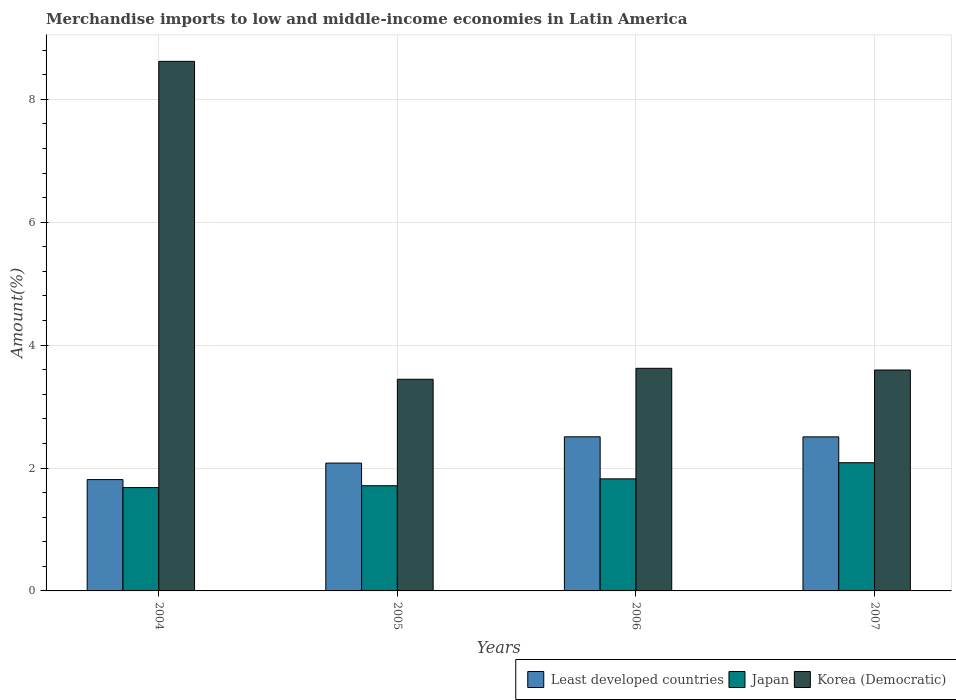Are the number of bars on each tick of the X-axis equal?
Your answer should be compact. Yes. How many bars are there on the 2nd tick from the left?
Keep it short and to the point. 3. What is the label of the 2nd group of bars from the left?
Provide a succinct answer. 2005. What is the percentage of amount earned from merchandise imports in Korea (Democratic) in 2005?
Keep it short and to the point. 3.44. Across all years, what is the maximum percentage of amount earned from merchandise imports in Korea (Democratic)?
Your response must be concise. 8.62. Across all years, what is the minimum percentage of amount earned from merchandise imports in Japan?
Make the answer very short. 1.68. What is the total percentage of amount earned from merchandise imports in Least developed countries in the graph?
Offer a very short reply. 8.91. What is the difference between the percentage of amount earned from merchandise imports in Least developed countries in 2005 and that in 2006?
Your response must be concise. -0.43. What is the difference between the percentage of amount earned from merchandise imports in Korea (Democratic) in 2005 and the percentage of amount earned from merchandise imports in Least developed countries in 2006?
Keep it short and to the point. 0.94. What is the average percentage of amount earned from merchandise imports in Japan per year?
Offer a terse response. 1.83. In the year 2004, what is the difference between the percentage of amount earned from merchandise imports in Korea (Democratic) and percentage of amount earned from merchandise imports in Least developed countries?
Provide a succinct answer. 6.81. What is the ratio of the percentage of amount earned from merchandise imports in Least developed countries in 2005 to that in 2007?
Your response must be concise. 0.83. Is the difference between the percentage of amount earned from merchandise imports in Korea (Democratic) in 2005 and 2006 greater than the difference between the percentage of amount earned from merchandise imports in Least developed countries in 2005 and 2006?
Ensure brevity in your answer.  Yes. What is the difference between the highest and the second highest percentage of amount earned from merchandise imports in Least developed countries?
Give a very brief answer. 0. What is the difference between the highest and the lowest percentage of amount earned from merchandise imports in Least developed countries?
Ensure brevity in your answer.  0.7. In how many years, is the percentage of amount earned from merchandise imports in Least developed countries greater than the average percentage of amount earned from merchandise imports in Least developed countries taken over all years?
Keep it short and to the point. 2. What does the 1st bar from the left in 2005 represents?
Ensure brevity in your answer.  Least developed countries. What does the 1st bar from the right in 2004 represents?
Make the answer very short. Korea (Democratic). How many bars are there?
Keep it short and to the point. 12. Are all the bars in the graph horizontal?
Offer a terse response. No. What is the difference between two consecutive major ticks on the Y-axis?
Provide a succinct answer. 2. Are the values on the major ticks of Y-axis written in scientific E-notation?
Give a very brief answer. No. Does the graph contain any zero values?
Offer a very short reply. No. Does the graph contain grids?
Your answer should be compact. Yes. How many legend labels are there?
Keep it short and to the point. 3. How are the legend labels stacked?
Your answer should be very brief. Horizontal. What is the title of the graph?
Your answer should be compact. Merchandise imports to low and middle-income economies in Latin America. What is the label or title of the Y-axis?
Give a very brief answer. Amount(%). What is the Amount(%) of Least developed countries in 2004?
Offer a very short reply. 1.81. What is the Amount(%) in Japan in 2004?
Your answer should be compact. 1.68. What is the Amount(%) in Korea (Democratic) in 2004?
Provide a succinct answer. 8.62. What is the Amount(%) of Least developed countries in 2005?
Give a very brief answer. 2.08. What is the Amount(%) in Japan in 2005?
Provide a succinct answer. 1.71. What is the Amount(%) of Korea (Democratic) in 2005?
Offer a terse response. 3.44. What is the Amount(%) of Least developed countries in 2006?
Give a very brief answer. 2.51. What is the Amount(%) in Japan in 2006?
Offer a terse response. 1.82. What is the Amount(%) of Korea (Democratic) in 2006?
Your answer should be compact. 3.62. What is the Amount(%) of Least developed countries in 2007?
Your answer should be very brief. 2.51. What is the Amount(%) of Japan in 2007?
Offer a terse response. 2.09. What is the Amount(%) of Korea (Democratic) in 2007?
Give a very brief answer. 3.59. Across all years, what is the maximum Amount(%) in Least developed countries?
Offer a terse response. 2.51. Across all years, what is the maximum Amount(%) of Japan?
Keep it short and to the point. 2.09. Across all years, what is the maximum Amount(%) of Korea (Democratic)?
Keep it short and to the point. 8.62. Across all years, what is the minimum Amount(%) of Least developed countries?
Your response must be concise. 1.81. Across all years, what is the minimum Amount(%) in Japan?
Keep it short and to the point. 1.68. Across all years, what is the minimum Amount(%) of Korea (Democratic)?
Make the answer very short. 3.44. What is the total Amount(%) in Least developed countries in the graph?
Your answer should be compact. 8.91. What is the total Amount(%) of Japan in the graph?
Your response must be concise. 7.3. What is the total Amount(%) of Korea (Democratic) in the graph?
Your answer should be very brief. 19.28. What is the difference between the Amount(%) in Least developed countries in 2004 and that in 2005?
Provide a short and direct response. -0.27. What is the difference between the Amount(%) of Japan in 2004 and that in 2005?
Offer a very short reply. -0.03. What is the difference between the Amount(%) of Korea (Democratic) in 2004 and that in 2005?
Offer a terse response. 5.17. What is the difference between the Amount(%) in Least developed countries in 2004 and that in 2006?
Offer a terse response. -0.7. What is the difference between the Amount(%) in Japan in 2004 and that in 2006?
Your answer should be very brief. -0.14. What is the difference between the Amount(%) of Korea (Democratic) in 2004 and that in 2006?
Give a very brief answer. 5. What is the difference between the Amount(%) in Least developed countries in 2004 and that in 2007?
Your response must be concise. -0.7. What is the difference between the Amount(%) of Japan in 2004 and that in 2007?
Offer a very short reply. -0.4. What is the difference between the Amount(%) in Korea (Democratic) in 2004 and that in 2007?
Offer a terse response. 5.02. What is the difference between the Amount(%) of Least developed countries in 2005 and that in 2006?
Keep it short and to the point. -0.43. What is the difference between the Amount(%) of Japan in 2005 and that in 2006?
Give a very brief answer. -0.11. What is the difference between the Amount(%) of Korea (Democratic) in 2005 and that in 2006?
Keep it short and to the point. -0.18. What is the difference between the Amount(%) in Least developed countries in 2005 and that in 2007?
Make the answer very short. -0.43. What is the difference between the Amount(%) in Japan in 2005 and that in 2007?
Offer a terse response. -0.37. What is the difference between the Amount(%) in Korea (Democratic) in 2005 and that in 2007?
Make the answer very short. -0.15. What is the difference between the Amount(%) of Least developed countries in 2006 and that in 2007?
Offer a very short reply. 0. What is the difference between the Amount(%) of Japan in 2006 and that in 2007?
Your answer should be compact. -0.26. What is the difference between the Amount(%) of Korea (Democratic) in 2006 and that in 2007?
Provide a succinct answer. 0.03. What is the difference between the Amount(%) of Least developed countries in 2004 and the Amount(%) of Japan in 2005?
Offer a very short reply. 0.1. What is the difference between the Amount(%) in Least developed countries in 2004 and the Amount(%) in Korea (Democratic) in 2005?
Offer a very short reply. -1.63. What is the difference between the Amount(%) of Japan in 2004 and the Amount(%) of Korea (Democratic) in 2005?
Provide a short and direct response. -1.76. What is the difference between the Amount(%) of Least developed countries in 2004 and the Amount(%) of Japan in 2006?
Your answer should be compact. -0.01. What is the difference between the Amount(%) in Least developed countries in 2004 and the Amount(%) in Korea (Democratic) in 2006?
Offer a terse response. -1.81. What is the difference between the Amount(%) in Japan in 2004 and the Amount(%) in Korea (Democratic) in 2006?
Your answer should be very brief. -1.94. What is the difference between the Amount(%) of Least developed countries in 2004 and the Amount(%) of Japan in 2007?
Provide a short and direct response. -0.27. What is the difference between the Amount(%) in Least developed countries in 2004 and the Amount(%) in Korea (Democratic) in 2007?
Offer a very short reply. -1.78. What is the difference between the Amount(%) in Japan in 2004 and the Amount(%) in Korea (Democratic) in 2007?
Offer a very short reply. -1.91. What is the difference between the Amount(%) of Least developed countries in 2005 and the Amount(%) of Japan in 2006?
Your answer should be compact. 0.26. What is the difference between the Amount(%) of Least developed countries in 2005 and the Amount(%) of Korea (Democratic) in 2006?
Keep it short and to the point. -1.54. What is the difference between the Amount(%) in Japan in 2005 and the Amount(%) in Korea (Democratic) in 2006?
Ensure brevity in your answer.  -1.91. What is the difference between the Amount(%) in Least developed countries in 2005 and the Amount(%) in Japan in 2007?
Keep it short and to the point. -0.01. What is the difference between the Amount(%) of Least developed countries in 2005 and the Amount(%) of Korea (Democratic) in 2007?
Your response must be concise. -1.51. What is the difference between the Amount(%) in Japan in 2005 and the Amount(%) in Korea (Democratic) in 2007?
Keep it short and to the point. -1.88. What is the difference between the Amount(%) in Least developed countries in 2006 and the Amount(%) in Japan in 2007?
Provide a short and direct response. 0.42. What is the difference between the Amount(%) in Least developed countries in 2006 and the Amount(%) in Korea (Democratic) in 2007?
Offer a terse response. -1.09. What is the difference between the Amount(%) of Japan in 2006 and the Amount(%) of Korea (Democratic) in 2007?
Keep it short and to the point. -1.77. What is the average Amount(%) of Least developed countries per year?
Make the answer very short. 2.23. What is the average Amount(%) of Japan per year?
Keep it short and to the point. 1.83. What is the average Amount(%) in Korea (Democratic) per year?
Offer a very short reply. 4.82. In the year 2004, what is the difference between the Amount(%) of Least developed countries and Amount(%) of Japan?
Give a very brief answer. 0.13. In the year 2004, what is the difference between the Amount(%) of Least developed countries and Amount(%) of Korea (Democratic)?
Provide a short and direct response. -6.81. In the year 2004, what is the difference between the Amount(%) of Japan and Amount(%) of Korea (Democratic)?
Provide a short and direct response. -6.94. In the year 2005, what is the difference between the Amount(%) of Least developed countries and Amount(%) of Japan?
Provide a short and direct response. 0.37. In the year 2005, what is the difference between the Amount(%) of Least developed countries and Amount(%) of Korea (Democratic)?
Provide a short and direct response. -1.36. In the year 2005, what is the difference between the Amount(%) of Japan and Amount(%) of Korea (Democratic)?
Provide a short and direct response. -1.73. In the year 2006, what is the difference between the Amount(%) of Least developed countries and Amount(%) of Japan?
Provide a short and direct response. 0.68. In the year 2006, what is the difference between the Amount(%) of Least developed countries and Amount(%) of Korea (Democratic)?
Make the answer very short. -1.11. In the year 2006, what is the difference between the Amount(%) of Japan and Amount(%) of Korea (Democratic)?
Offer a terse response. -1.8. In the year 2007, what is the difference between the Amount(%) of Least developed countries and Amount(%) of Japan?
Make the answer very short. 0.42. In the year 2007, what is the difference between the Amount(%) in Least developed countries and Amount(%) in Korea (Democratic)?
Offer a terse response. -1.09. In the year 2007, what is the difference between the Amount(%) of Japan and Amount(%) of Korea (Democratic)?
Your answer should be compact. -1.51. What is the ratio of the Amount(%) in Least developed countries in 2004 to that in 2005?
Give a very brief answer. 0.87. What is the ratio of the Amount(%) of Japan in 2004 to that in 2005?
Provide a succinct answer. 0.98. What is the ratio of the Amount(%) of Korea (Democratic) in 2004 to that in 2005?
Make the answer very short. 2.5. What is the ratio of the Amount(%) of Least developed countries in 2004 to that in 2006?
Ensure brevity in your answer.  0.72. What is the ratio of the Amount(%) in Japan in 2004 to that in 2006?
Provide a short and direct response. 0.92. What is the ratio of the Amount(%) in Korea (Democratic) in 2004 to that in 2006?
Make the answer very short. 2.38. What is the ratio of the Amount(%) of Least developed countries in 2004 to that in 2007?
Make the answer very short. 0.72. What is the ratio of the Amount(%) in Japan in 2004 to that in 2007?
Provide a short and direct response. 0.81. What is the ratio of the Amount(%) of Korea (Democratic) in 2004 to that in 2007?
Provide a short and direct response. 2.4. What is the ratio of the Amount(%) in Least developed countries in 2005 to that in 2006?
Make the answer very short. 0.83. What is the ratio of the Amount(%) in Japan in 2005 to that in 2006?
Keep it short and to the point. 0.94. What is the ratio of the Amount(%) of Korea (Democratic) in 2005 to that in 2006?
Your answer should be compact. 0.95. What is the ratio of the Amount(%) in Least developed countries in 2005 to that in 2007?
Give a very brief answer. 0.83. What is the ratio of the Amount(%) in Japan in 2005 to that in 2007?
Give a very brief answer. 0.82. What is the ratio of the Amount(%) of Korea (Democratic) in 2005 to that in 2007?
Give a very brief answer. 0.96. What is the ratio of the Amount(%) in Least developed countries in 2006 to that in 2007?
Offer a terse response. 1. What is the ratio of the Amount(%) of Japan in 2006 to that in 2007?
Offer a terse response. 0.87. What is the ratio of the Amount(%) of Korea (Democratic) in 2006 to that in 2007?
Make the answer very short. 1.01. What is the difference between the highest and the second highest Amount(%) of Least developed countries?
Make the answer very short. 0. What is the difference between the highest and the second highest Amount(%) in Japan?
Offer a terse response. 0.26. What is the difference between the highest and the second highest Amount(%) in Korea (Democratic)?
Give a very brief answer. 5. What is the difference between the highest and the lowest Amount(%) in Least developed countries?
Keep it short and to the point. 0.7. What is the difference between the highest and the lowest Amount(%) in Japan?
Your answer should be compact. 0.4. What is the difference between the highest and the lowest Amount(%) in Korea (Democratic)?
Give a very brief answer. 5.17. 